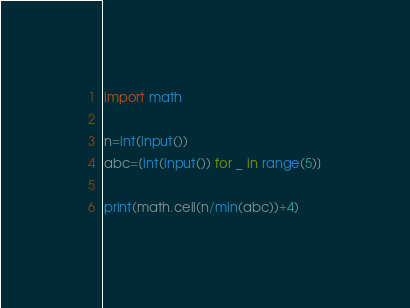Convert code to text. <code><loc_0><loc_0><loc_500><loc_500><_Python_>import math

n=int(input())
abc=[int(input()) for _ in range(5)]

print(math.ceil(n/min(abc))+4)</code> 